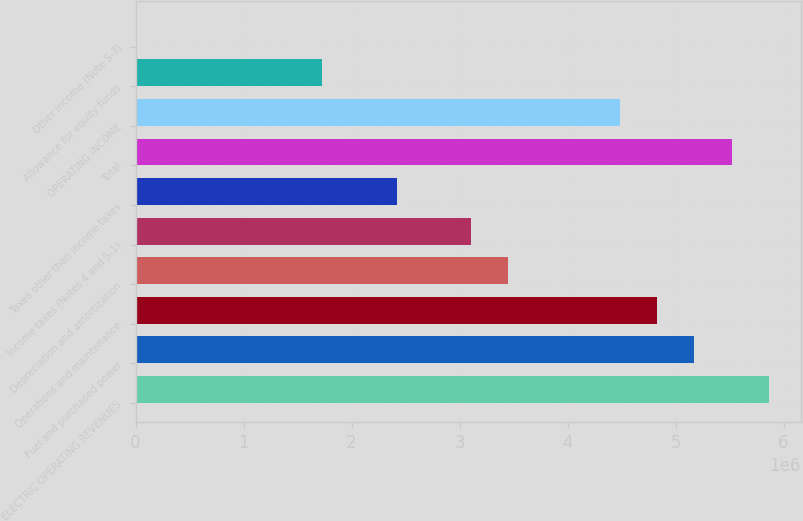Convert chart. <chart><loc_0><loc_0><loc_500><loc_500><bar_chart><fcel>ELECTRIC OPERATING REVENUES<fcel>Fuel and purchased power<fcel>Operations and maintenance<fcel>Depreciation and amortization<fcel>Income taxes (Notes 4 and S-1)<fcel>Taxes other than income taxes<fcel>Total<fcel>OPERATING INCOME<fcel>Allowance for equity funds<fcel>Other income (Note S-3)<nl><fcel>5.8644e+06<fcel>5.17493e+06<fcel>4.83019e+06<fcel>3.45125e+06<fcel>3.10652e+06<fcel>2.41704e+06<fcel>5.51966e+06<fcel>4.48546e+06<fcel>1.72757e+06<fcel>3896<nl></chart> 